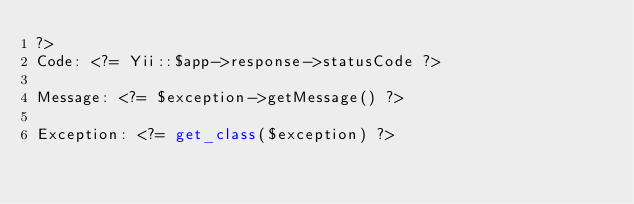<code> <loc_0><loc_0><loc_500><loc_500><_PHP_>?>
Code: <?= Yii::$app->response->statusCode ?>

Message: <?= $exception->getMessage() ?>

Exception: <?= get_class($exception) ?></code> 